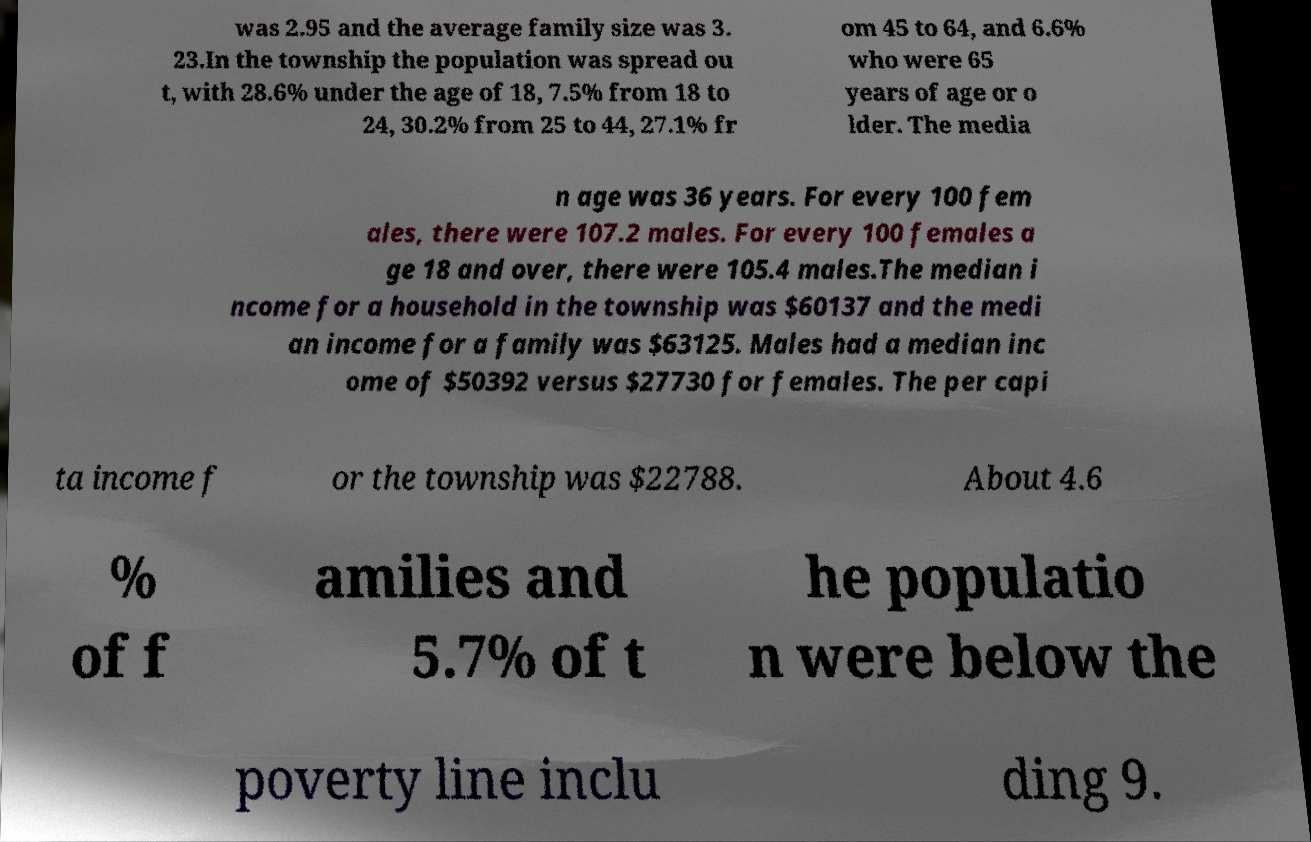Please read and relay the text visible in this image. What does it say? was 2.95 and the average family size was 3. 23.In the township the population was spread ou t, with 28.6% under the age of 18, 7.5% from 18 to 24, 30.2% from 25 to 44, 27.1% fr om 45 to 64, and 6.6% who were 65 years of age or o lder. The media n age was 36 years. For every 100 fem ales, there were 107.2 males. For every 100 females a ge 18 and over, there were 105.4 males.The median i ncome for a household in the township was $60137 and the medi an income for a family was $63125. Males had a median inc ome of $50392 versus $27730 for females. The per capi ta income f or the township was $22788. About 4.6 % of f amilies and 5.7% of t he populatio n were below the poverty line inclu ding 9. 